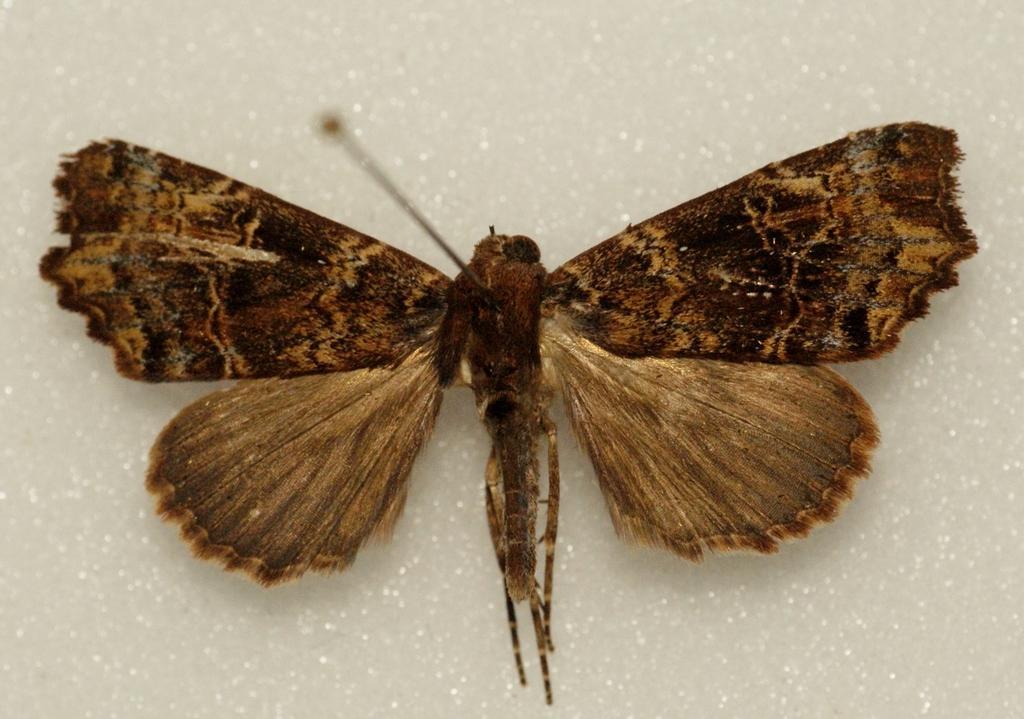Can you describe this image briefly? In this image I can see a butterfly which is in brown and black color. It is on the white surface. 